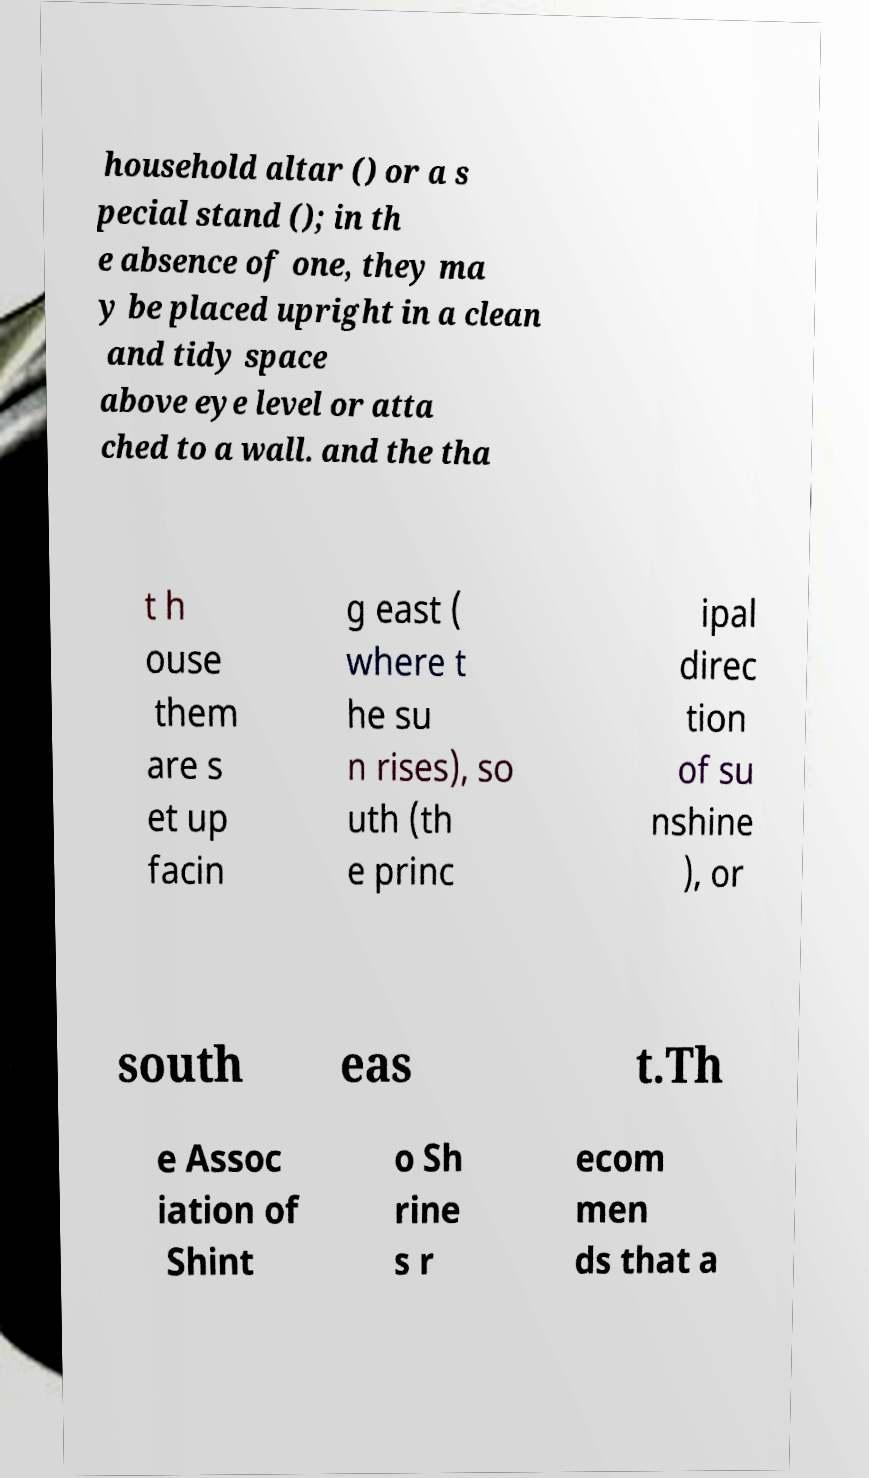Please identify and transcribe the text found in this image. household altar () or a s pecial stand (); in th e absence of one, they ma y be placed upright in a clean and tidy space above eye level or atta ched to a wall. and the tha t h ouse them are s et up facin g east ( where t he su n rises), so uth (th e princ ipal direc tion of su nshine ), or south eas t.Th e Assoc iation of Shint o Sh rine s r ecom men ds that a 